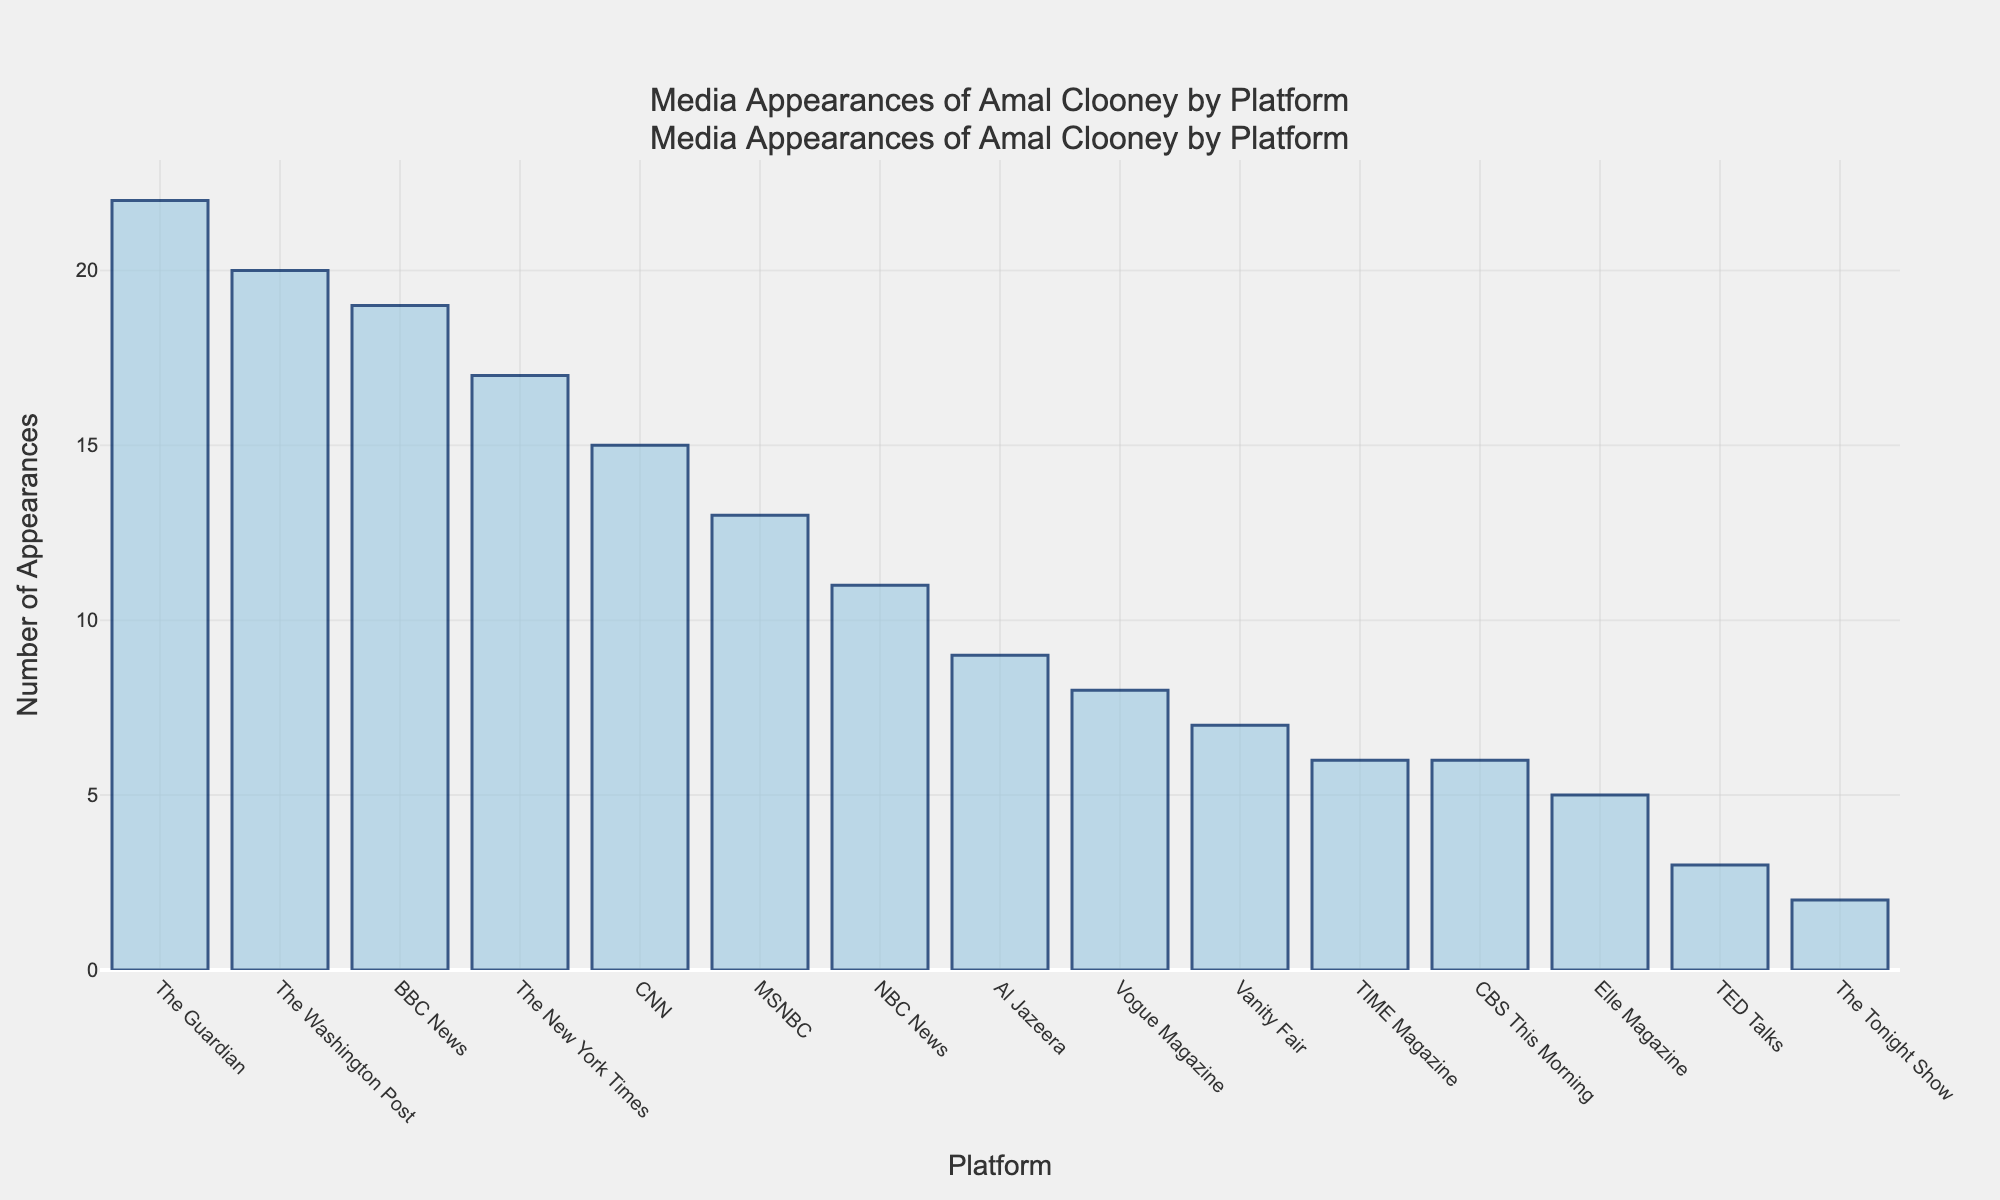Which platform has the highest number of appearances? The highest bar in the chart represents the platform with the most appearances. By observing the bars, you can see that The Guardian has the highest number.
Answer: The Guardian Which platform has the fewest number of appearances? The shortest bar in the chart represents the platform with the fewest appearances. By observing the bars, The Tonight Show has the lowest number.
Answer: The Tonight Show How many more appearances does The Guardian have compared to Vogue Magazine? The number of appearances for The Guardian is 22, and for Vogue Magazine, it is 8. The difference is calculated by subtracting 8 from 22.
Answer: 14 What is the total number of appearances across all platforms? Sum all the appearances: 15 (CNN) + 8 (Vogue Magazine) + 22 (The Guardian) + 11 (NBC News) + 6 (TIME Magazine) + 19 (BBC News) + 3 (TED Talks) + 17 (The New York Times) + 5 (Elle Magazine) + 9 (Al Jazeera) + 2 (The Tonight Show) + 7 (Vanity Fair) + 13 (MSNBC) + 20 (The Washington Post) + 6 (CBS This Morning).
Answer: 163 What is the median number of appearances? Sort the appearances in ascending order: 2, 3, 5, 6, 6, 7, 8, 9, 11, 13, 15, 17, 19, 20, 22. The median value is the middle number in this sorted list.
Answer: 11 Which two platforms have nearly the same number of appearances? By visually inspecting the bars and their heights, we see that TIME Magazine and CBS This Morning have very similar heights, with both having 6 appearances each.
Answer: TIME Magazine and CBS This Morning How many platforms have more than 15 appearances? Count the number of bars that extend above the 15 mark on the y-axis. The platforms are CNN, The Guardian, BBC News, The New York Times, and The Washington Post.
Answer: 5 What is the combined total of appearances on MSNBC and BBC News? Add the number of appearances for MSNBC (13) and BBC News (19).
Answer: 32 Comparatively, how does Al Jazeera's number of appearances stand with respect to BBC News and MSNBC? Al Jazeera has 9 appearances. BBC News has 10 more appearances than Al Jazeera (19 total), and MSNBC has 4 more appearances than Al Jazeera (13 total).
Answer: Less 